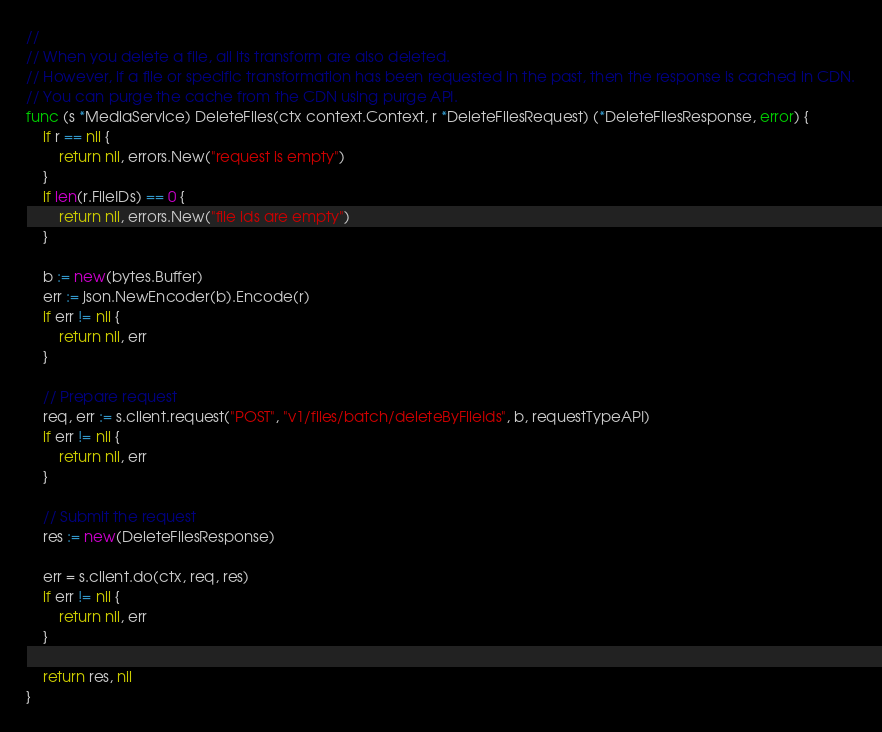<code> <loc_0><loc_0><loc_500><loc_500><_Go_>//
// When you delete a file, all its transform are also deleted.
// However, if a file or specific transformation has been requested in the past, then the response is cached in CDN.
// You can purge the cache from the CDN using purge API.
func (s *MediaService) DeleteFiles(ctx context.Context, r *DeleteFilesRequest) (*DeleteFilesResponse, error) {
	if r == nil {
		return nil, errors.New("request is empty")
	}
	if len(r.FileIDs) == 0 {
		return nil, errors.New("file ids are empty")
	}

	b := new(bytes.Buffer)
	err := json.NewEncoder(b).Encode(r)
	if err != nil {
		return nil, err
	}

	// Prepare request
	req, err := s.client.request("POST", "v1/files/batch/deleteByFileIds", b, requestTypeAPI)
	if err != nil {
		return nil, err
	}

	// Submit the request
	res := new(DeleteFilesResponse)

	err = s.client.do(ctx, req, res)
	if err != nil {
		return nil, err
	}

	return res, nil
}
</code> 